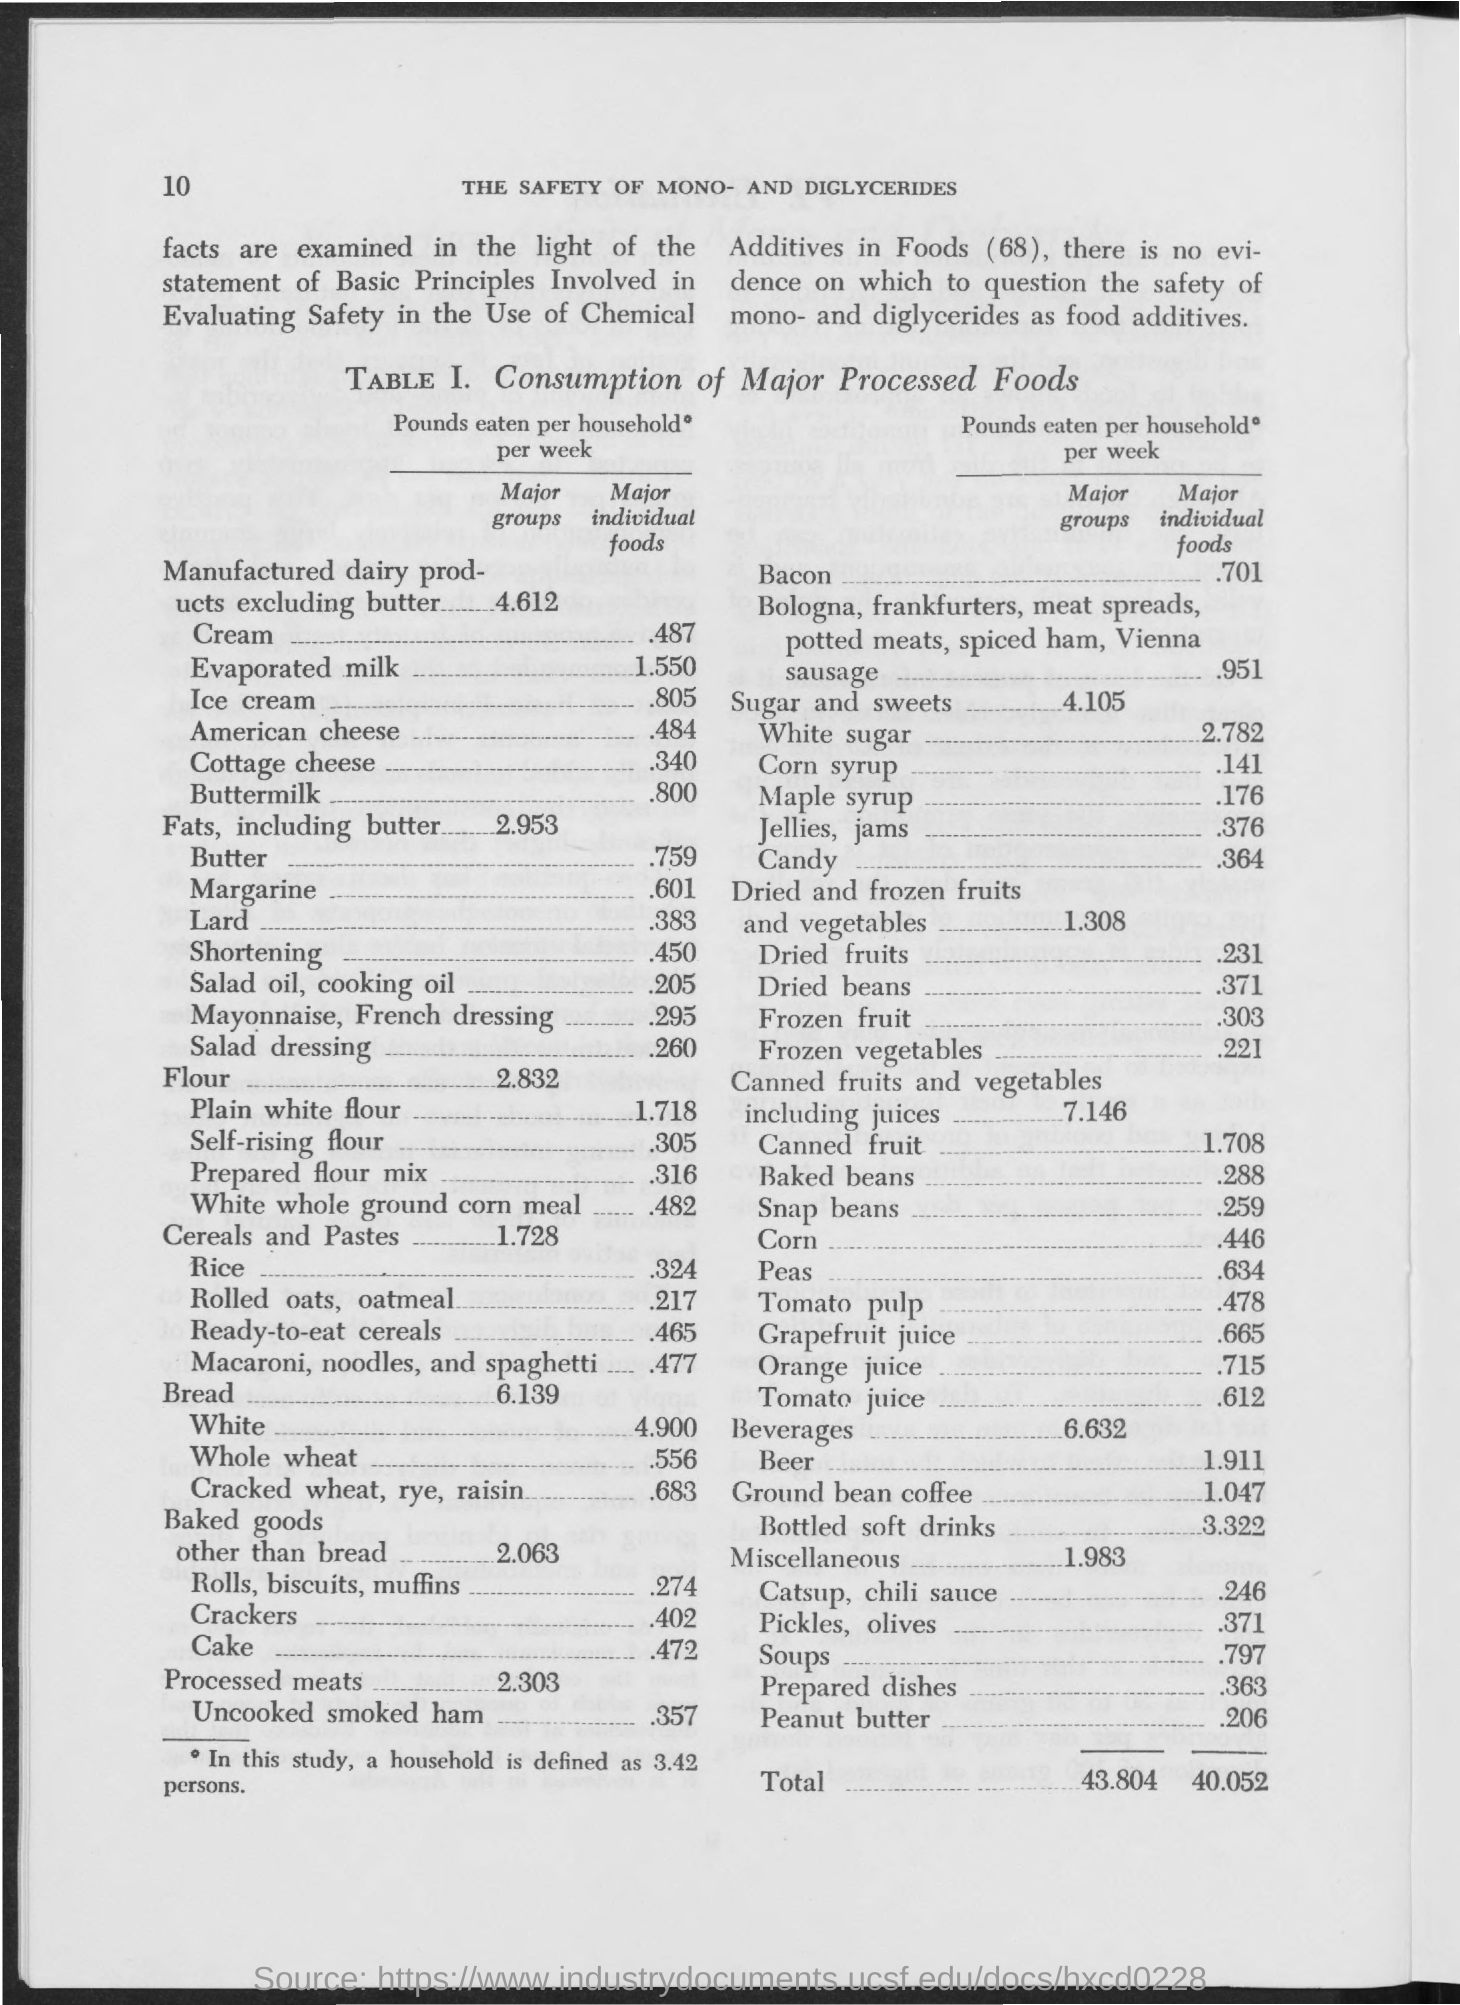What is the title of Table 1?
Your answer should be compact. Consumption of Major Processed Foods. In this study, how many persons is a household defined as?
Ensure brevity in your answer.  3.42 persons. 